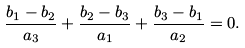<formula> <loc_0><loc_0><loc_500><loc_500>\frac { b _ { 1 } - b _ { 2 } } { a _ { 3 } } + \frac { b _ { 2 } - b _ { 3 } } { a _ { 1 } } + \frac { b _ { 3 } - b _ { 1 } } { a _ { 2 } } = 0 .</formula> 